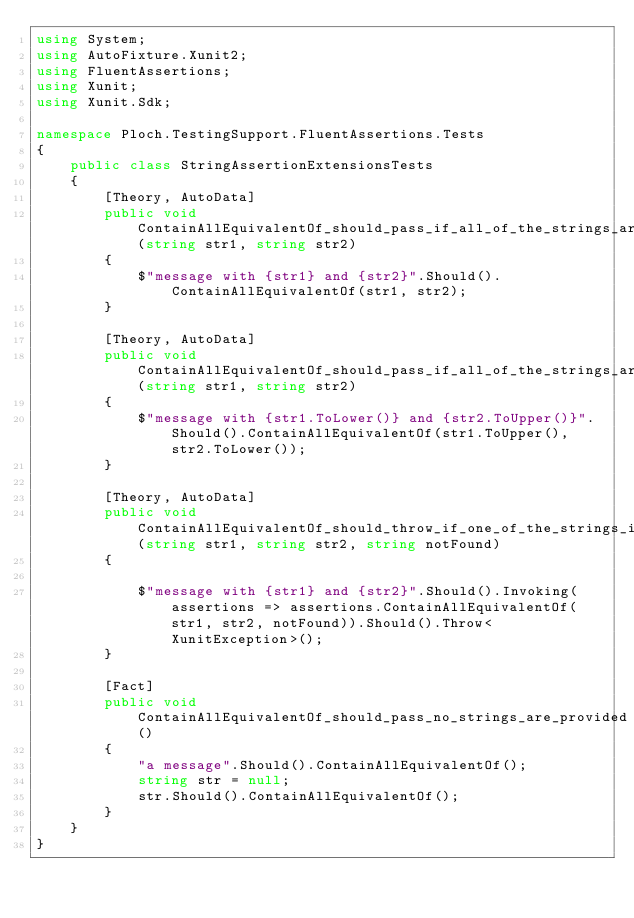<code> <loc_0><loc_0><loc_500><loc_500><_C#_>using System;
using AutoFixture.Xunit2;
using FluentAssertions;
using Xunit;
using Xunit.Sdk;

namespace Ploch.TestingSupport.FluentAssertions.Tests
{
    public class StringAssertionExtensionsTests
    {
        [Theory, AutoData]
        public void ContainAllEquivalentOf_should_pass_if_all_of_the_strings_are_found(string str1, string str2)
        {
            $"message with {str1} and {str2}".Should().ContainAllEquivalentOf(str1, str2);
        }

        [Theory, AutoData]
        public void ContainAllEquivalentOf_should_pass_if_all_of_the_strings_are_found_in_any_case(string str1, string str2)
        {
            $"message with {str1.ToLower()} and {str2.ToUpper()}".Should().ContainAllEquivalentOf(str1.ToUpper(), str2.ToLower());
        }

        [Theory, AutoData]
        public void ContainAllEquivalentOf_should_throw_if_one_of_the_strings_is_not_found(string str1, string str2, string notFound)
        {

            $"message with {str1} and {str2}".Should().Invoking(assertions => assertions.ContainAllEquivalentOf(str1, str2, notFound)).Should().Throw<XunitException>();
        }

        [Fact]
        public void ContainAllEquivalentOf_should_pass_no_strings_are_provided()
        {
            "a message".Should().ContainAllEquivalentOf();
            string str = null;
            str.Should().ContainAllEquivalentOf();
        }
    }
}
</code> 